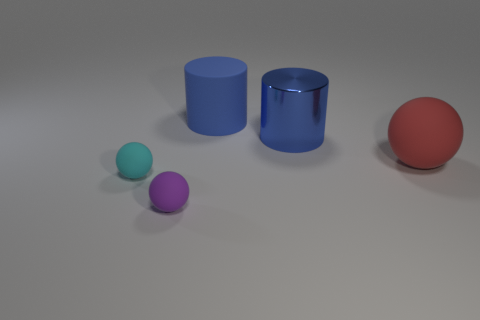Subtract all large matte spheres. How many spheres are left? 2 Add 3 green blocks. How many objects exist? 8 Subtract all red spheres. How many spheres are left? 2 Subtract all cylinders. How many objects are left? 3 Subtract 3 spheres. How many spheres are left? 0 Subtract all green cylinders. Subtract all yellow cubes. How many cylinders are left? 2 Subtract 0 yellow spheres. How many objects are left? 5 Subtract all green cubes. How many red balls are left? 1 Subtract all blue metallic spheres. Subtract all metallic cylinders. How many objects are left? 4 Add 2 metallic cylinders. How many metallic cylinders are left? 3 